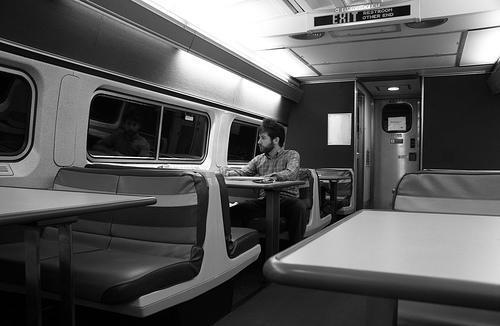How many dining tables are there?
Give a very brief answer. 2. How many benches can you see?
Give a very brief answer. 2. 